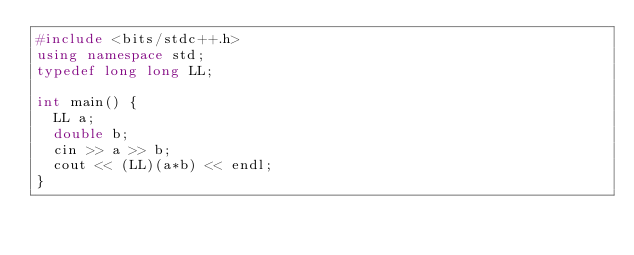Convert code to text. <code><loc_0><loc_0><loc_500><loc_500><_C++_>#include <bits/stdc++.h>
using namespace std;
typedef long long LL;

int main() {
  LL a;
  double b;
  cin >> a >> b;
  cout << (LL)(a*b) << endl;
}</code> 